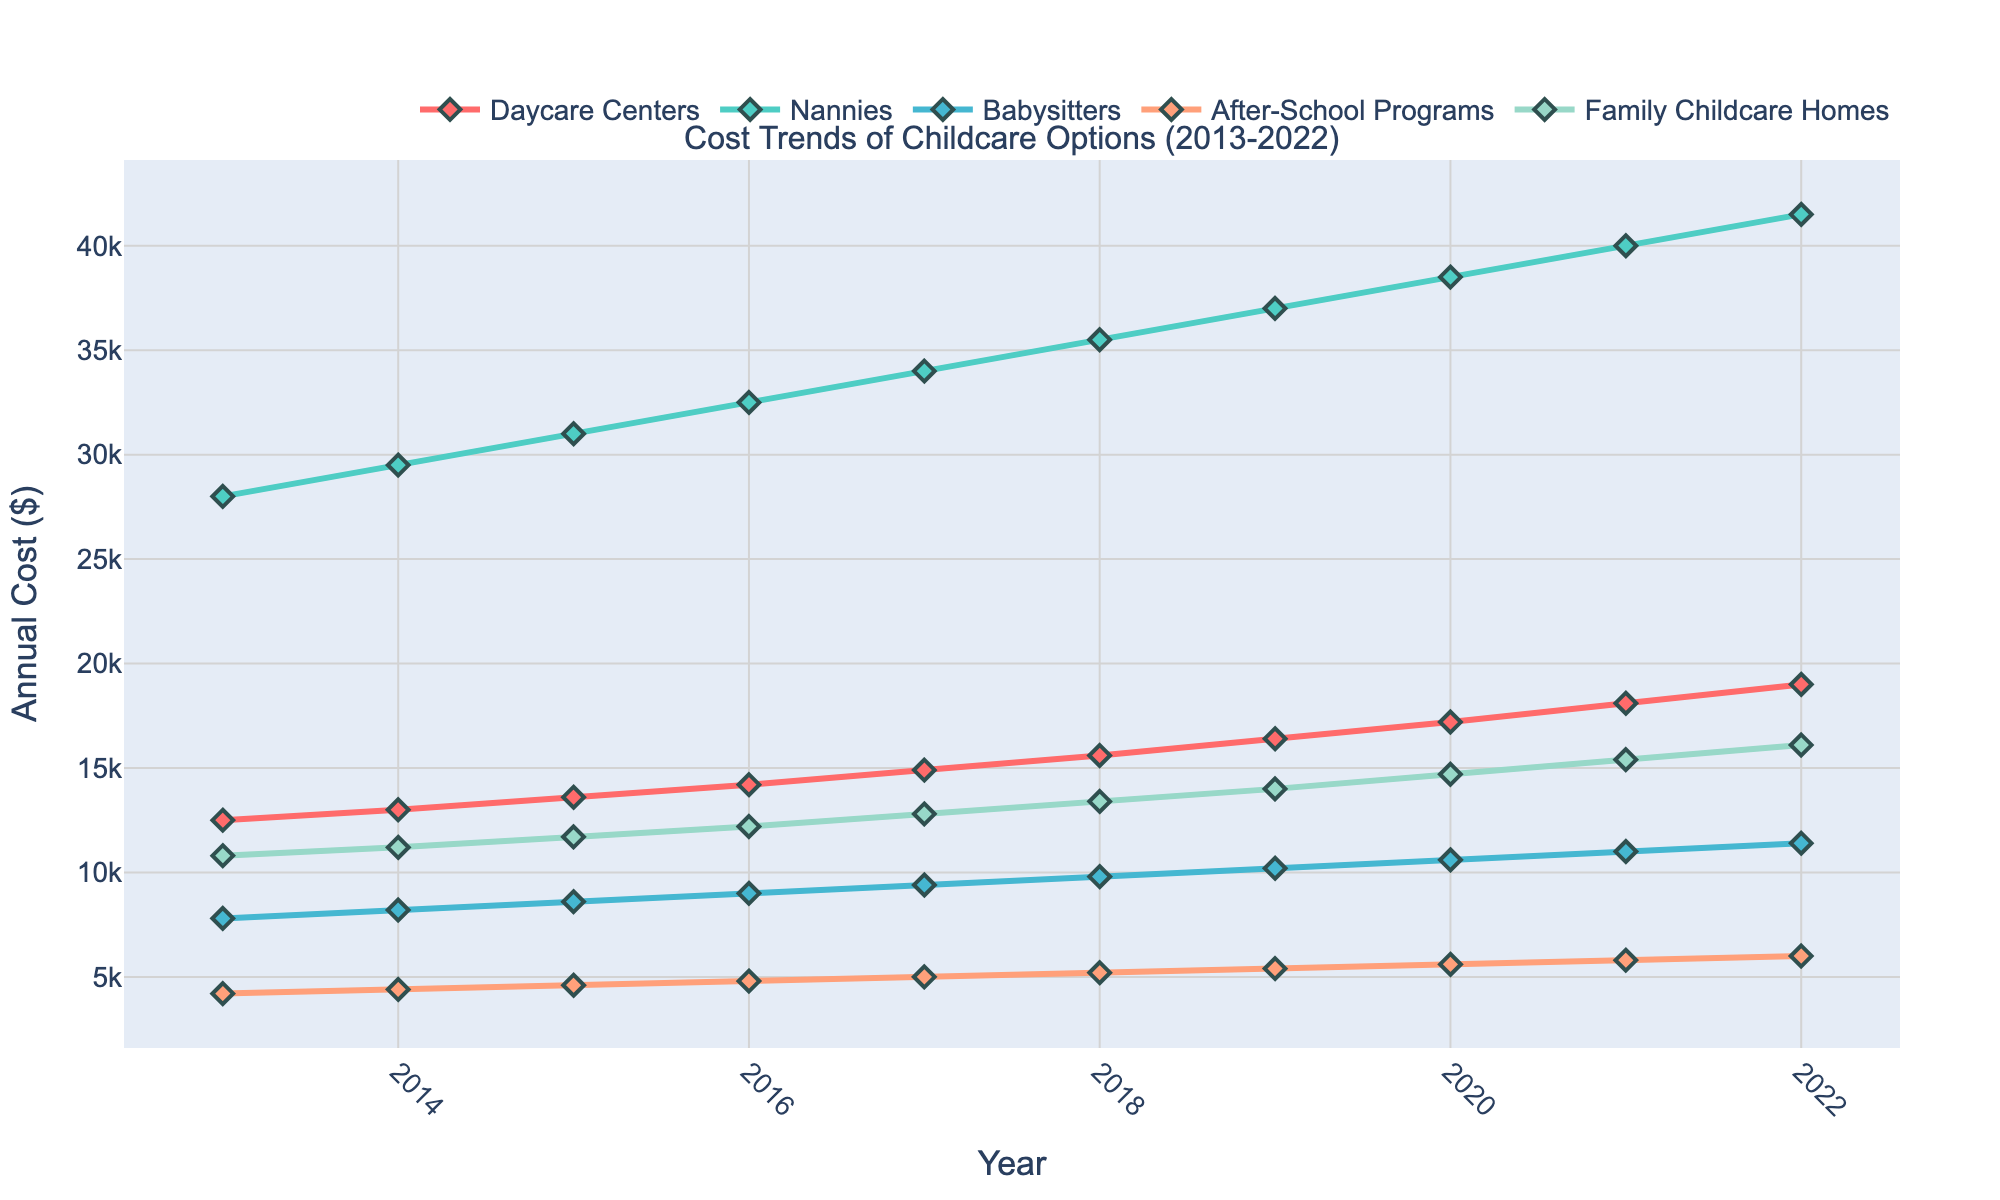What is the highest annual cost for nannies in the past decade? The highest annual cost for nannies can be found by identifying the highest point of the line representing nannies on the chart. The line representing nannies peaks at $41,500 in 2022.
Answer: $41,500 Which childcare option had the most significant increase in cost from 2013 to 2022? To determine which childcare option had the most significant increase, calculate the difference between the cost in 2022 and 2013 for each option. Nannies had an increase from $28,000 in 2013 to $41,500 in 2022, which is the largest increase compared to other options.
Answer: Nannies What was the cost of family childcare homes in 2017? Locate the year 2017 on the x-axis and find the corresponding point on the line for family childcare homes. The cost is represented by a point at $12,800 in 2017.
Answer: $12,800 By how much did the cost of daycare centers increase from 2016 to 2019? To find the increase in cost from 2016 to 2019, subtract the cost in 2016 ($14,200) from the cost in 2019 ($16,400). So, the increase is $16,400 - $14,200 = $2,200.
Answer: $2,200 Which year did after-school programs cross the $5,000 mark in cost? Find the point on the after-school programs line where the cost first exceeds $5,000. In 2017, the line surpasses the $5,000 mark.
Answer: 2017 What trend can we observe for babysitters over the past decade? By examining the line representing babysitters, we can see that the cost steadily increases every year. Starting from $7,800 in 2013 and rising to $11,400 in 2022, the trend is a consistent increase.
Answer: Consistent increase At what year did the cost of family childcare homes reach $15,400? Find the point on the family childcare homes line that reaches $15,400. This happens in the year 2021.
Answer: 2021 Which childcare option had the lowest cost in 2022? Compare the endpoints of all lines at 2022. After-school programs had the lowest cost at $6,000.
Answer: After-school programs What's the average cost of daycare centers from 2013 to 2022? Sum the annual costs for daycare centers from 2013 to 2022 and divide by the number of years (10). ($12,500 + $13,000 + $13,600 + $14,200 + $14,900 + $15,600 + $16,400 + $17,200 + $18,100 + $19,000) / 10 = $15,950.
Answer: $15,950 By how much did the annual cost of nannies increase every year on average? The increase in cost for nannies from 2013 ($28,000) to 2022 ($41,500) is $13,500 over 9 intervals. Calculate the average annual increase: $13,500 / 9 = $1,500 per year.
Answer: $1,500 